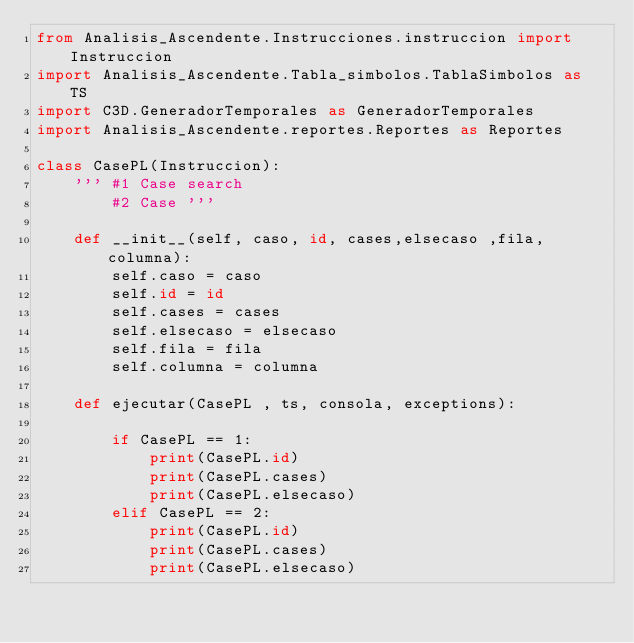Convert code to text. <code><loc_0><loc_0><loc_500><loc_500><_Python_>from Analisis_Ascendente.Instrucciones.instruccion import Instruccion
import Analisis_Ascendente.Tabla_simbolos.TablaSimbolos as TS
import C3D.GeneradorTemporales as GeneradorTemporales
import Analisis_Ascendente.reportes.Reportes as Reportes

class CasePL(Instruccion):
    ''' #1 Case search
        #2 Case '''

    def __init__(self, caso, id, cases,elsecaso ,fila, columna):
        self.caso = caso
        self.id = id
        self.cases = cases
        self.elsecaso = elsecaso
        self.fila = fila
        self.columna = columna

    def ejecutar(CasePL , ts, consola, exceptions):

        if CasePL == 1:
            print(CasePL.id)
            print(CasePL.cases)
            print(CasePL.elsecaso)
        elif CasePL == 2:
            print(CasePL.id)
            print(CasePL.cases)
            print(CasePL.elsecaso)

</code> 